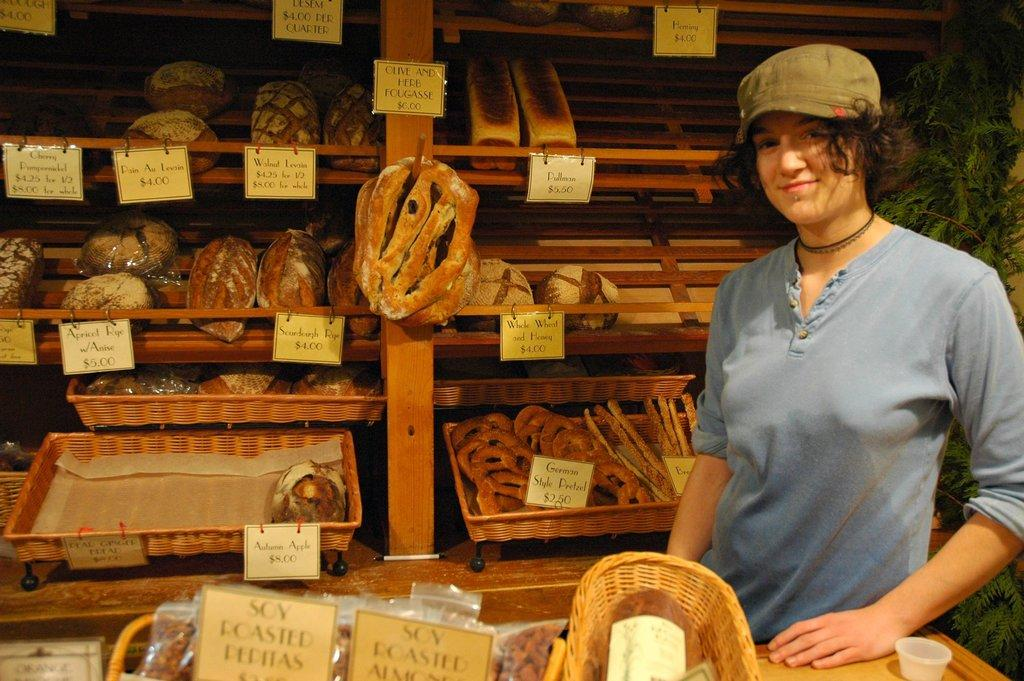<image>
Create a compact narrative representing the image presented. A woman in a hat standing next to some bread with types such as Sourdough Rye for $4.00. 